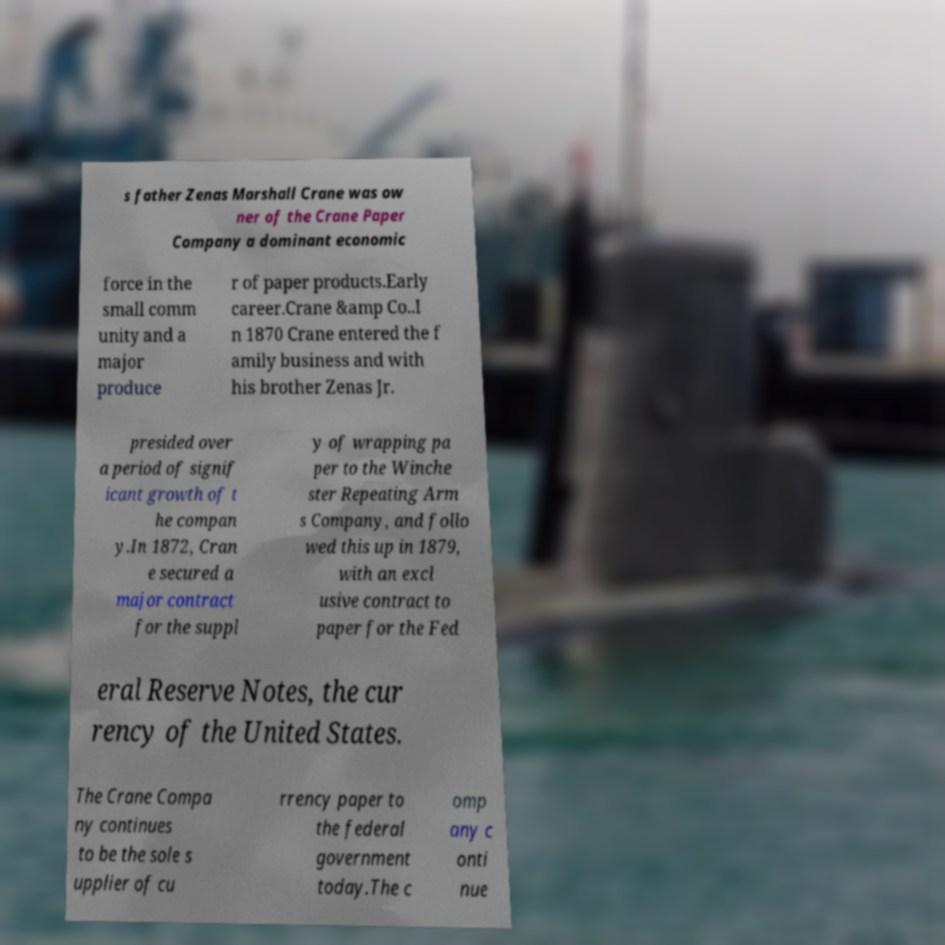For documentation purposes, I need the text within this image transcribed. Could you provide that? s father Zenas Marshall Crane was ow ner of the Crane Paper Company a dominant economic force in the small comm unity and a major produce r of paper products.Early career.Crane &amp Co..I n 1870 Crane entered the f amily business and with his brother Zenas Jr. presided over a period of signif icant growth of t he compan y.In 1872, Cran e secured a major contract for the suppl y of wrapping pa per to the Winche ster Repeating Arm s Company, and follo wed this up in 1879, with an excl usive contract to paper for the Fed eral Reserve Notes, the cur rency of the United States. The Crane Compa ny continues to be the sole s upplier of cu rrency paper to the federal government today.The c omp any c onti nue 